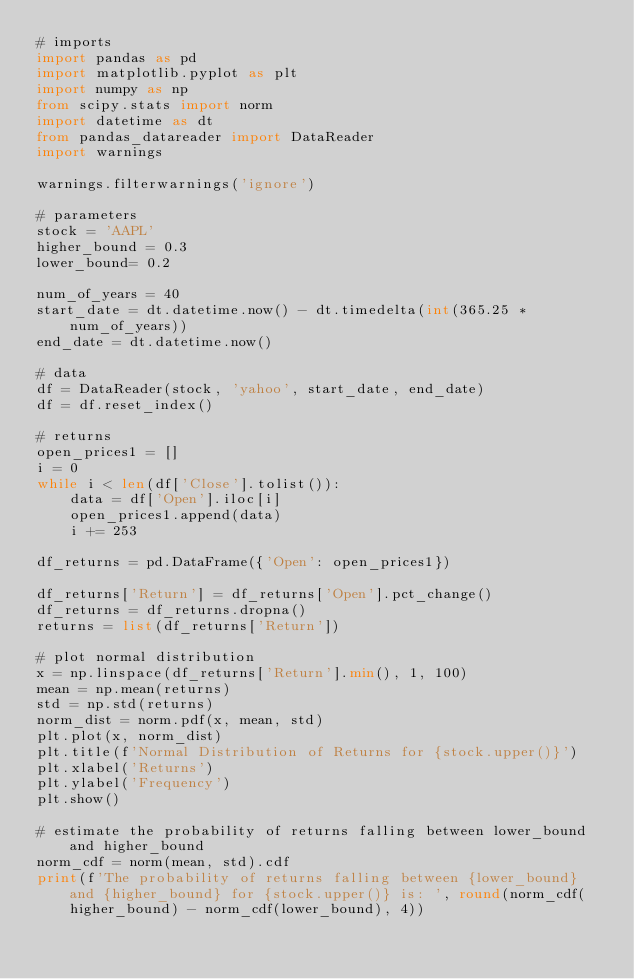Convert code to text. <code><loc_0><loc_0><loc_500><loc_500><_Python_># imports
import pandas as pd
import matplotlib.pyplot as plt
import numpy as np
from scipy.stats import norm
import datetime as dt
from pandas_datareader import DataReader
import warnings

warnings.filterwarnings('ignore')

# parameters
stock = 'AAPL'
higher_bound = 0.3
lower_bound= 0.2

num_of_years = 40
start_date = dt.datetime.now() - dt.timedelta(int(365.25 * num_of_years))
end_date = dt.datetime.now() 

# data
df = DataReader(stock, 'yahoo', start_date, end_date)
df = df.reset_index()

# returns
open_prices1 = []
i = 0
while i < len(df['Close'].tolist()):
    data = df['Open'].iloc[i]
    open_prices1.append(data)
    i += 253
    
df_returns = pd.DataFrame({'Open': open_prices1})

df_returns['Return'] = df_returns['Open'].pct_change()
df_returns = df_returns.dropna()
returns = list(df_returns['Return'])

# plot normal distribution
x = np.linspace(df_returns['Return'].min(), 1, 100)
mean = np.mean(returns)
std = np.std(returns)
norm_dist = norm.pdf(x, mean, std)
plt.plot(x, norm_dist)
plt.title(f'Normal Distribution of Returns for {stock.upper()}')
plt.xlabel('Returns')
plt.ylabel('Frequency')
plt.show()

# estimate the probability of returns falling between lower_bound and higher_bound
norm_cdf = norm(mean, std).cdf
print(f'The probability of returns falling between {lower_bound} and {higher_bound} for {stock.upper()} is: ', round(norm_cdf(higher_bound) - norm_cdf(lower_bound), 4))
</code> 